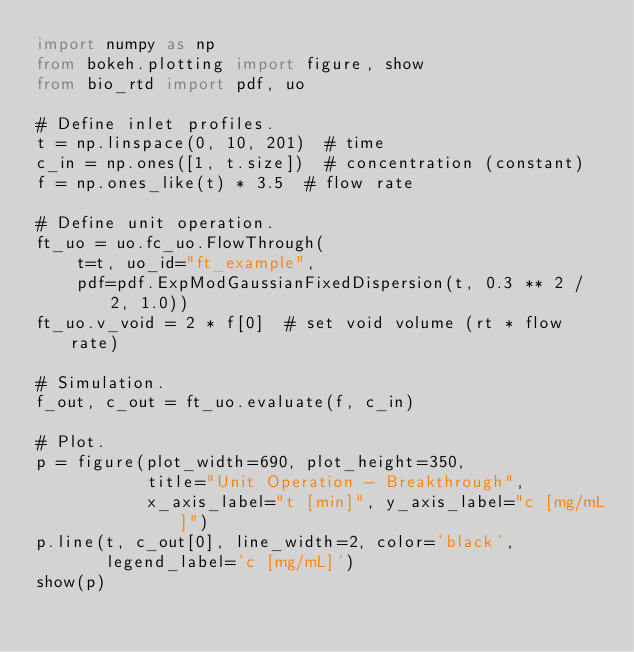<code> <loc_0><loc_0><loc_500><loc_500><_Python_>import numpy as np
from bokeh.plotting import figure, show
from bio_rtd import pdf, uo

# Define inlet profiles.
t = np.linspace(0, 10, 201)  # time
c_in = np.ones([1, t.size])  # concentration (constant)
f = np.ones_like(t) * 3.5  # flow rate

# Define unit operation.
ft_uo = uo.fc_uo.FlowThrough(
    t=t, uo_id="ft_example",
    pdf=pdf.ExpModGaussianFixedDispersion(t, 0.3 ** 2 / 2, 1.0))
ft_uo.v_void = 2 * f[0]  # set void volume (rt * flow rate)

# Simulation.
f_out, c_out = ft_uo.evaluate(f, c_in)

# Plot.
p = figure(plot_width=690, plot_height=350,
           title="Unit Operation - Breakthrough",
           x_axis_label="t [min]", y_axis_label="c [mg/mL]")
p.line(t, c_out[0], line_width=2, color='black',
       legend_label='c [mg/mL]')
show(p)
</code> 